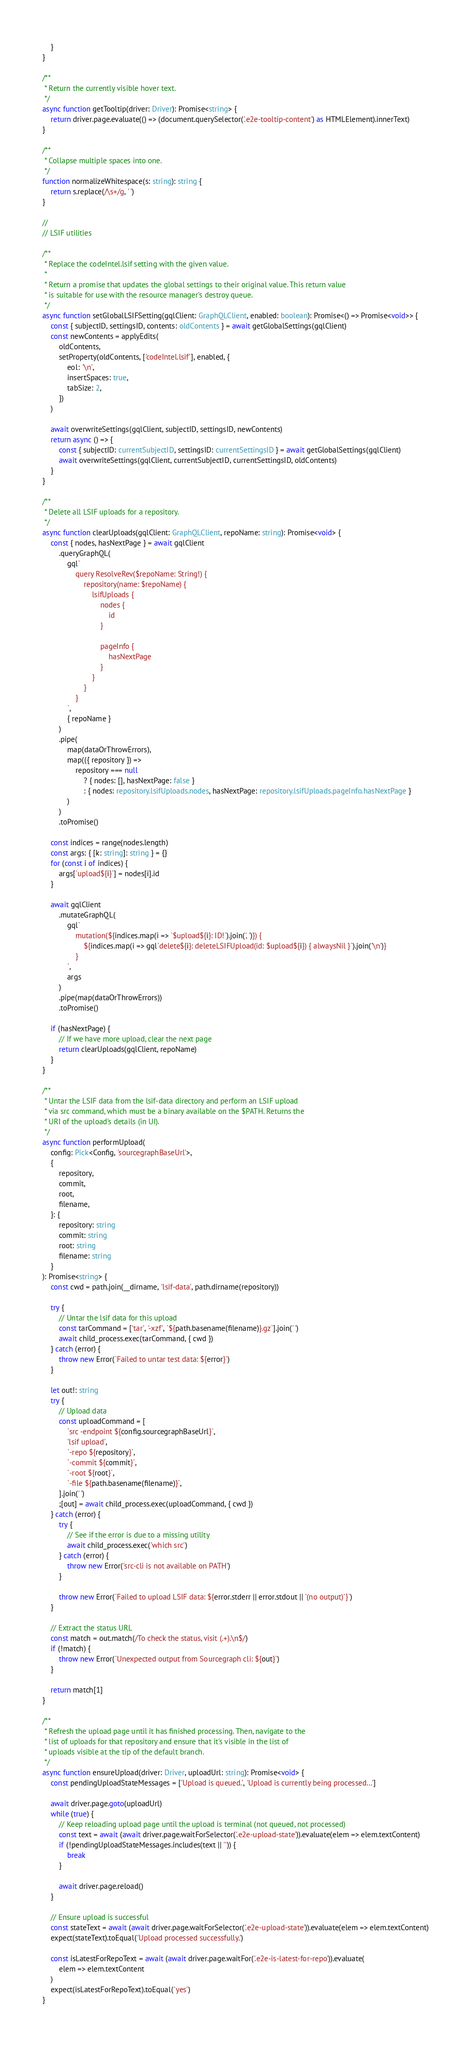<code> <loc_0><loc_0><loc_500><loc_500><_TypeScript_>    }
}

/**
 * Return the currently visible hover text.
 */
async function getTooltip(driver: Driver): Promise<string> {
    return driver.page.evaluate(() => (document.querySelector('.e2e-tooltip-content') as HTMLElement).innerText)
}

/**
 * Collapse multiple spaces into one.
 */
function normalizeWhitespace(s: string): string {
    return s.replace(/\s+/g, ' ')
}

//
// LSIF utilities

/**
 * Replace the codeIntel.lsif setting with the given value.
 *
 * Return a promise that updates the global settings to their original value. This return value
 * is suitable for use with the resource manager's destroy queue.
 */
async function setGlobalLSIFSetting(gqlClient: GraphQLClient, enabled: boolean): Promise<() => Promise<void>> {
    const { subjectID, settingsID, contents: oldContents } = await getGlobalSettings(gqlClient)
    const newContents = applyEdits(
        oldContents,
        setProperty(oldContents, ['codeIntel.lsif'], enabled, {
            eol: '\n',
            insertSpaces: true,
            tabSize: 2,
        })
    )

    await overwriteSettings(gqlClient, subjectID, settingsID, newContents)
    return async () => {
        const { subjectID: currentSubjectID, settingsID: currentSettingsID } = await getGlobalSettings(gqlClient)
        await overwriteSettings(gqlClient, currentSubjectID, currentSettingsID, oldContents)
    }
}

/**
 * Delete all LSIF uploads for a repository.
 */
async function clearUploads(gqlClient: GraphQLClient, repoName: string): Promise<void> {
    const { nodes, hasNextPage } = await gqlClient
        .queryGraphQL(
            gql`
                query ResolveRev($repoName: String!) {
                    repository(name: $repoName) {
                        lsifUploads {
                            nodes {
                                id
                            }

                            pageInfo {
                                hasNextPage
                            }
                        }
                    }
                }
            `,
            { repoName }
        )
        .pipe(
            map(dataOrThrowErrors),
            map(({ repository }) =>
                repository === null
                    ? { nodes: [], hasNextPage: false }
                    : { nodes: repository.lsifUploads.nodes, hasNextPage: repository.lsifUploads.pageInfo.hasNextPage }
            )
        )
        .toPromise()

    const indices = range(nodes.length)
    const args: { [k: string]: string } = {}
    for (const i of indices) {
        args[`upload${i}`] = nodes[i].id
    }

    await gqlClient
        .mutateGraphQL(
            gql`
                mutation(${indices.map(i => `$upload${i}: ID!`).join(', ')}) {
                    ${indices.map(i => gql`delete${i}: deleteLSIFUpload(id: $upload${i}) { alwaysNil }`).join('\n')}
                }
            `,
            args
        )
        .pipe(map(dataOrThrowErrors))
        .toPromise()

    if (hasNextPage) {
        // If we have more upload, clear the next page
        return clearUploads(gqlClient, repoName)
    }
}

/**
 * Untar the LSIF data from the lsif-data directory and perform an LSIF upload
 * via src command, which must be a binary available on the $PATH. Returns the
 * URI of the upload's details (in UI).
 */
async function performUpload(
    config: Pick<Config, 'sourcegraphBaseUrl'>,
    {
        repository,
        commit,
        root,
        filename,
    }: {
        repository: string
        commit: string
        root: string
        filename: string
    }
): Promise<string> {
    const cwd = path.join(__dirname, 'lsif-data', path.dirname(repository))

    try {
        // Untar the lsif data for this upload
        const tarCommand = ['tar', '-xzf', `${path.basename(filename)}.gz`].join(' ')
        await child_process.exec(tarCommand, { cwd })
    } catch (error) {
        throw new Error(`Failed to untar test data: ${error}`)
    }

    let out!: string
    try {
        // Upload data
        const uploadCommand = [
            `src -endpoint ${config.sourcegraphBaseUrl}`,
            'lsif upload',
            `-repo ${repository}`,
            `-commit ${commit}`,
            `-root ${root}`,
            `-file ${path.basename(filename)}`,
        ].join(' ')
        ;[out] = await child_process.exec(uploadCommand, { cwd })
    } catch (error) {
        try {
            // See if the error is due to a missing utility
            await child_process.exec('which src')
        } catch (error) {
            throw new Error('src-cli is not available on PATH')
        }

        throw new Error(`Failed to upload LSIF data: ${error.stderr || error.stdout || '(no output)'}`)
    }

    // Extract the status URL
    const match = out.match(/To check the status, visit (.+).\n$/)
    if (!match) {
        throw new Error(`Unexpected output from Sourcegraph cli: ${out}`)
    }

    return match[1]
}

/**
 * Refresh the upload page until it has finished processing. Then, navigate to the
 * list of uploads for that repository and ensure that it's visible in the list of
 * uploads visible at the tip of the default branch.
 */
async function ensureUpload(driver: Driver, uploadUrl: string): Promise<void> {
    const pendingUploadStateMessages = ['Upload is queued.', 'Upload is currently being processed...']

    await driver.page.goto(uploadUrl)
    while (true) {
        // Keep reloading upload page until the upload is terminal (not queued, not processed)
        const text = await (await driver.page.waitForSelector('.e2e-upload-state')).evaluate(elem => elem.textContent)
        if (!pendingUploadStateMessages.includes(text || '')) {
            break
        }

        await driver.page.reload()
    }

    // Ensure upload is successful
    const stateText = await (await driver.page.waitForSelector('.e2e-upload-state')).evaluate(elem => elem.textContent)
    expect(stateText).toEqual('Upload processed successfully.')

    const isLatestForRepoText = await (await driver.page.waitFor('.e2e-is-latest-for-repo')).evaluate(
        elem => elem.textContent
    )
    expect(isLatestForRepoText).toEqual('yes')
}
</code> 